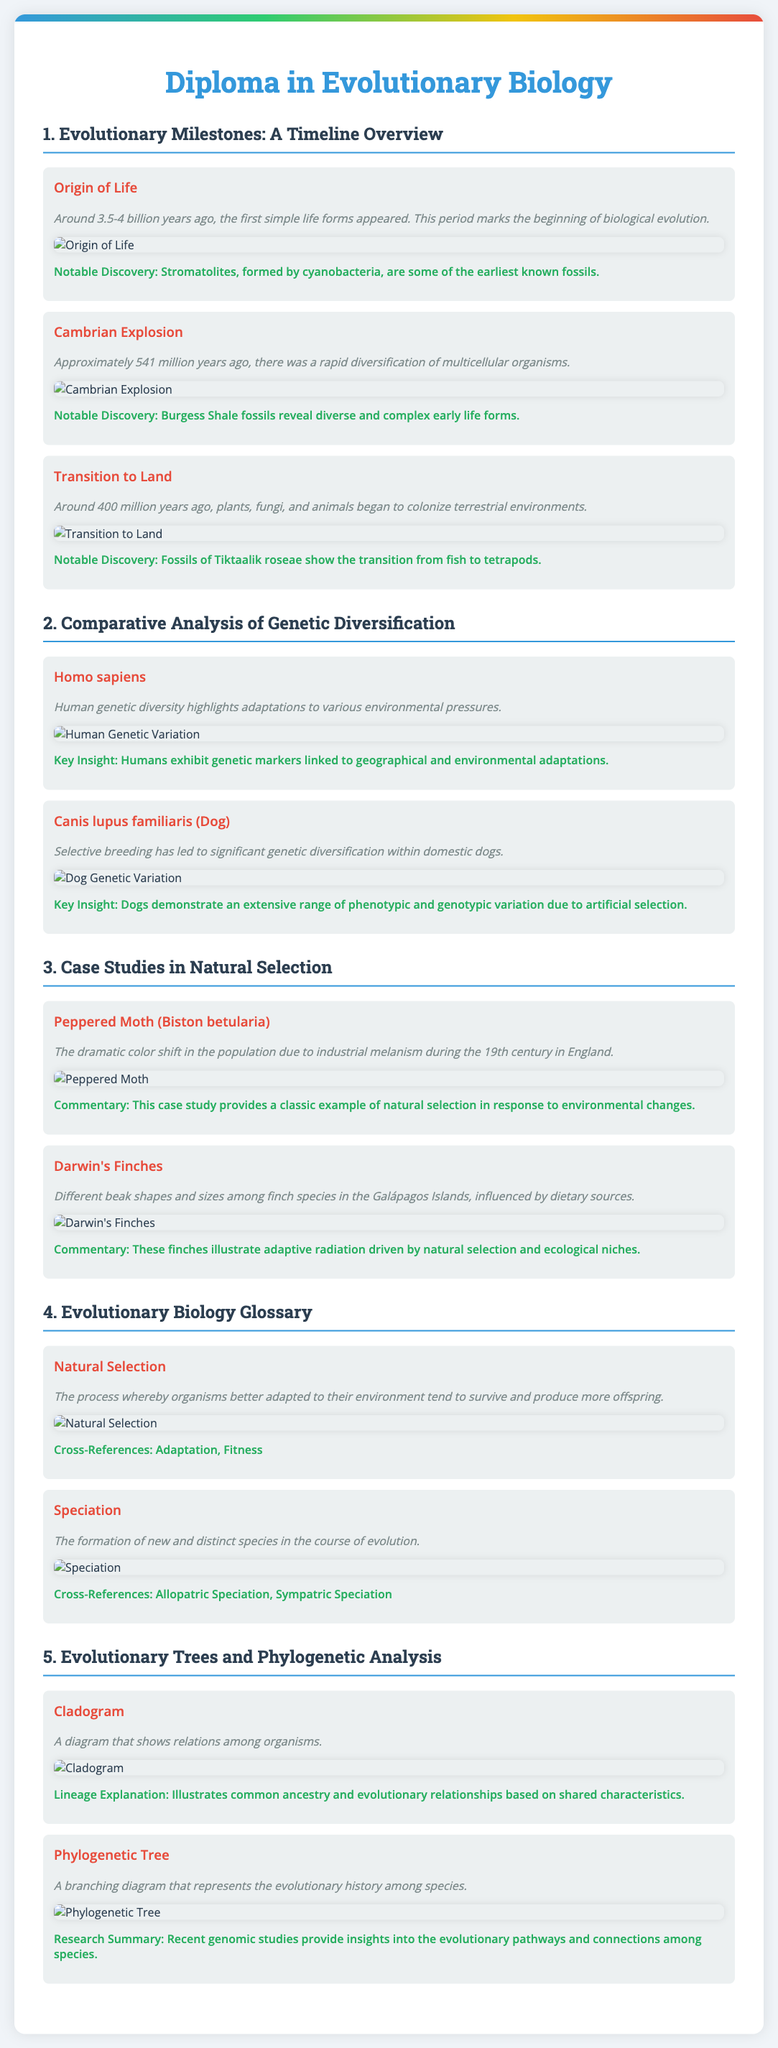What event marks the beginning of biological evolution? The document states that the Origin of Life is around 3.5-4 billion years ago and marks the beginning of biological evolution.
Answer: Origin of Life What significant event occurred approximately 541 million years ago? The document describes the Cambrian Explosion as a rapid diversification of multicellular organisms occurring around 541 million years ago.
Answer: Cambrian Explosion Which species shows significant genetic diversification due to selective breeding? The document mentions that domestic dogs, Canis lupus familiaris, exhibit significant genetic diversification due to selective breeding.
Answer: Canis lupus familiaris What is a key insight related to human genetic diversity? The document notes that humans exhibit genetic markers linked to geographical and environmental adaptations as a key insight.
Answer: Genetic markers linked to adaptations What example illustrates adaptive radiation driven by natural selection? The document states that Darwin's Finches illustrate adaptive radiation driven by natural selection and ecological niches.
Answer: Darwin's Finches What is the definition of natural selection according to the glossary? The document defines natural selection as the process whereby organisms better adapted to their environment tend to survive and produce more offspring.
Answer: Organisms better adapted to their environment What diagram type is used to show relations among organisms? The document refers to a Cladogram as a diagram that shows relations among organisms.
Answer: Cladogram Which fossil discovery is notable in the study of the transition to land? The fossil discovery of Tiktaalik roseae is highlighted in the document as notable for showing the transition from fish to tetrapods.
Answer: Tiktaalik roseae What evidence supports the understanding of common ancestry in evolutionary trees? The document explains that Cladograms illustrate common ancestry and evolutionary relationships based on shared characteristics.
Answer: Cladograms 